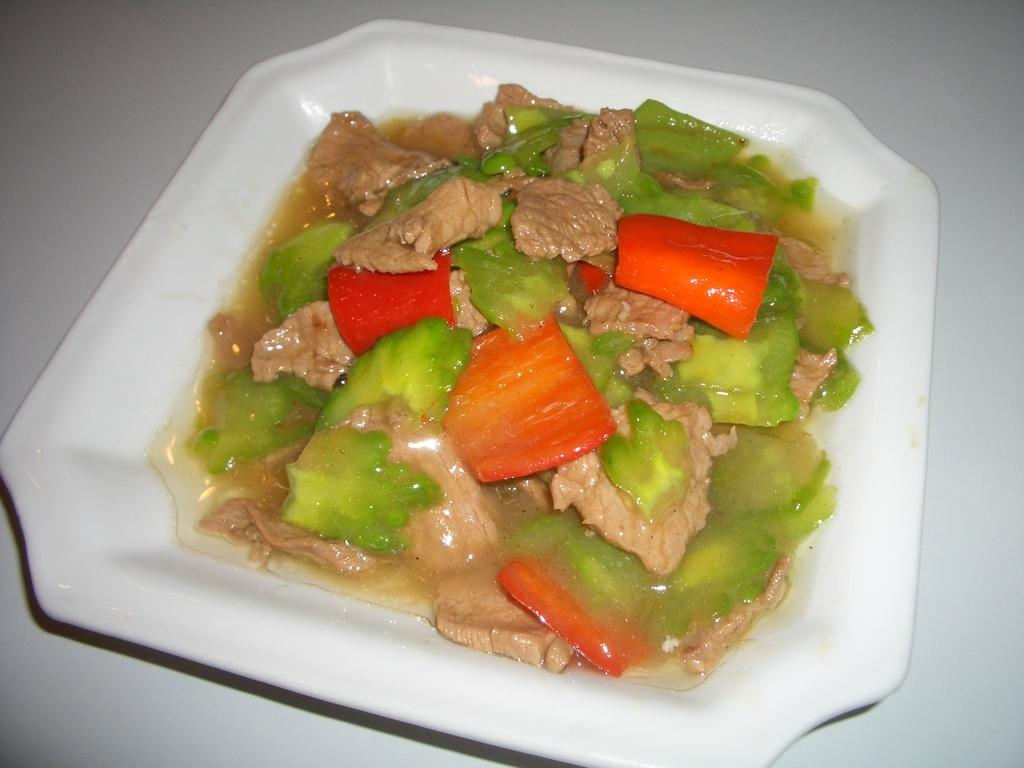What is the main object in the image? There is a dish in the image. How is the dish presented? The dish is served in a plate. Where is the plate with the dish located? The plate is placed on a table. What type of nail is being used to hold the dish in place on the table? There is no nail present in the image; the dish is simply placed on the plate, which is on the table. 